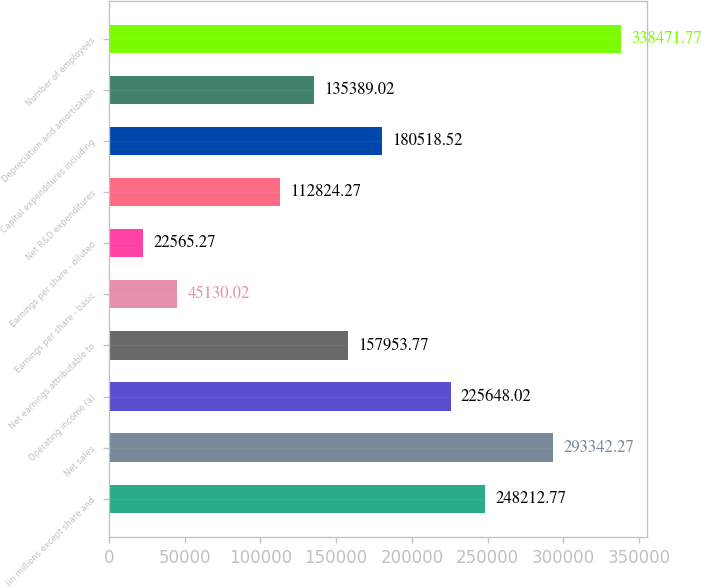<chart> <loc_0><loc_0><loc_500><loc_500><bar_chart><fcel>(in millions except share and<fcel>Net sales<fcel>Operating income (a)<fcel>Net earnings attributable to<fcel>Earnings per share - basic<fcel>Earnings per share - diluted<fcel>Net R&D expenditures<fcel>Capital expenditures including<fcel>Depreciation and amortization<fcel>Number of employees<nl><fcel>248213<fcel>293342<fcel>225648<fcel>157954<fcel>45130<fcel>22565.3<fcel>112824<fcel>180519<fcel>135389<fcel>338472<nl></chart> 